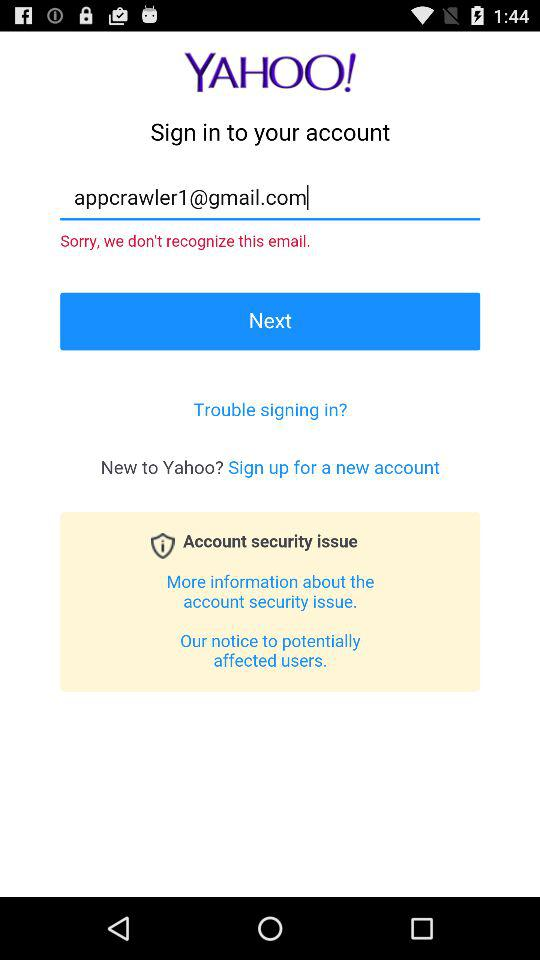Through what application can we sign in? You can sign in through "YAHOO!" application. 